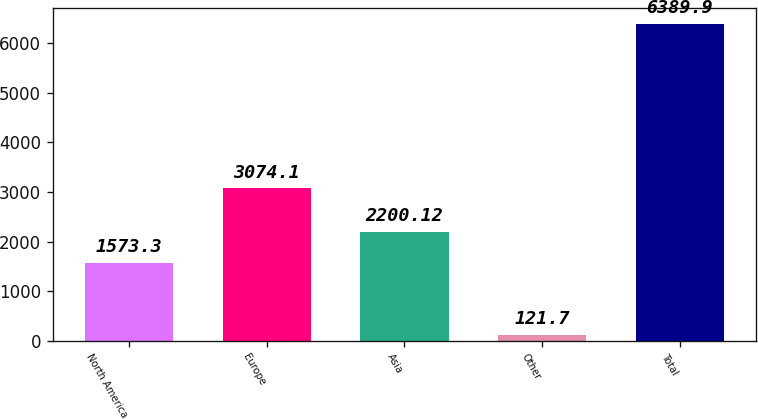Convert chart. <chart><loc_0><loc_0><loc_500><loc_500><bar_chart><fcel>North America<fcel>Europe<fcel>Asia<fcel>Other<fcel>Total<nl><fcel>1573.3<fcel>3074.1<fcel>2200.12<fcel>121.7<fcel>6389.9<nl></chart> 